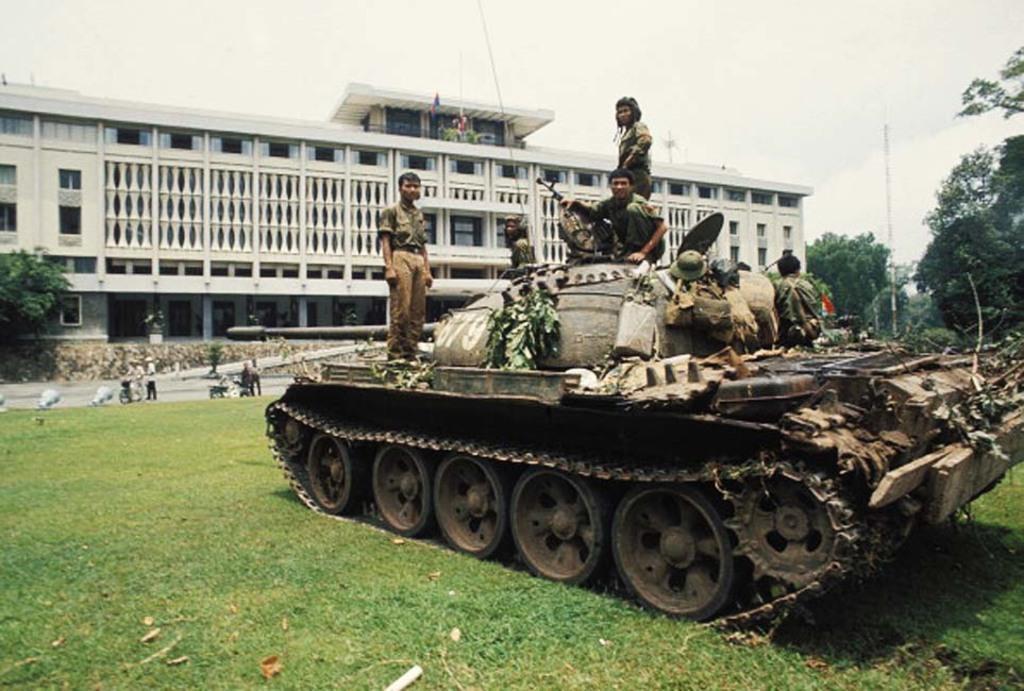How would you summarize this image in a sentence or two? In this picture there are people and we can see military tank on the grass. In the background of the image we can see building, pole, trees and sky. 